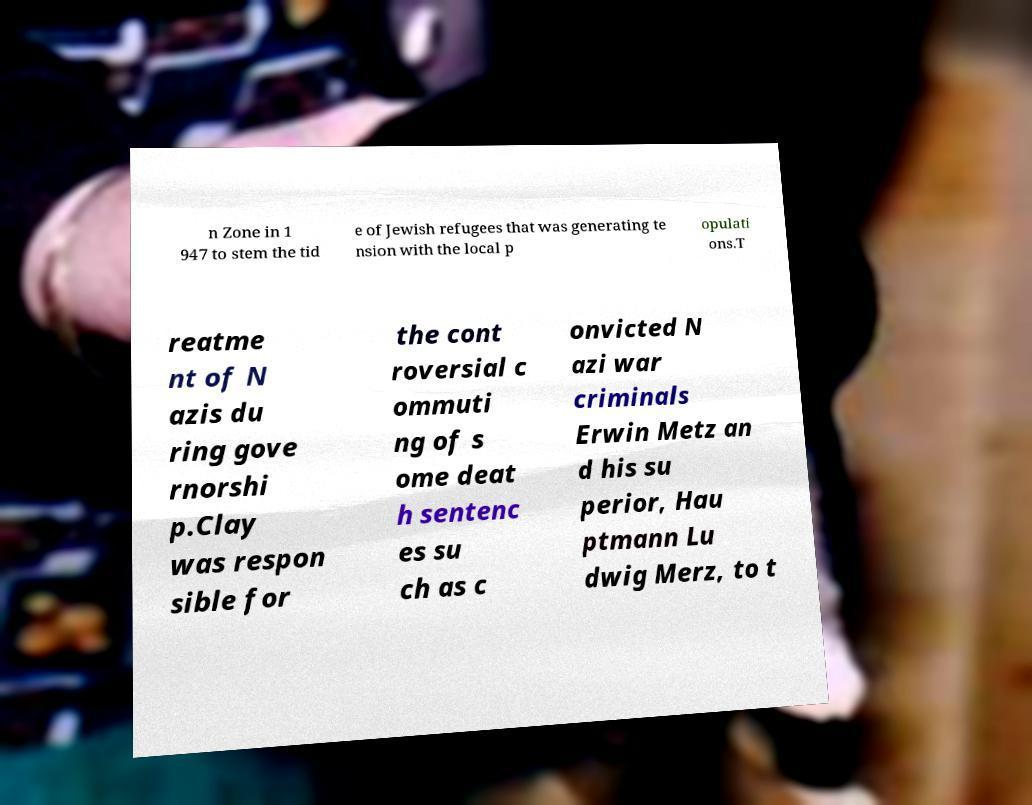There's text embedded in this image that I need extracted. Can you transcribe it verbatim? n Zone in 1 947 to stem the tid e of Jewish refugees that was generating te nsion with the local p opulati ons.T reatme nt of N azis du ring gove rnorshi p.Clay was respon sible for the cont roversial c ommuti ng of s ome deat h sentenc es su ch as c onvicted N azi war criminals Erwin Metz an d his su perior, Hau ptmann Lu dwig Merz, to t 